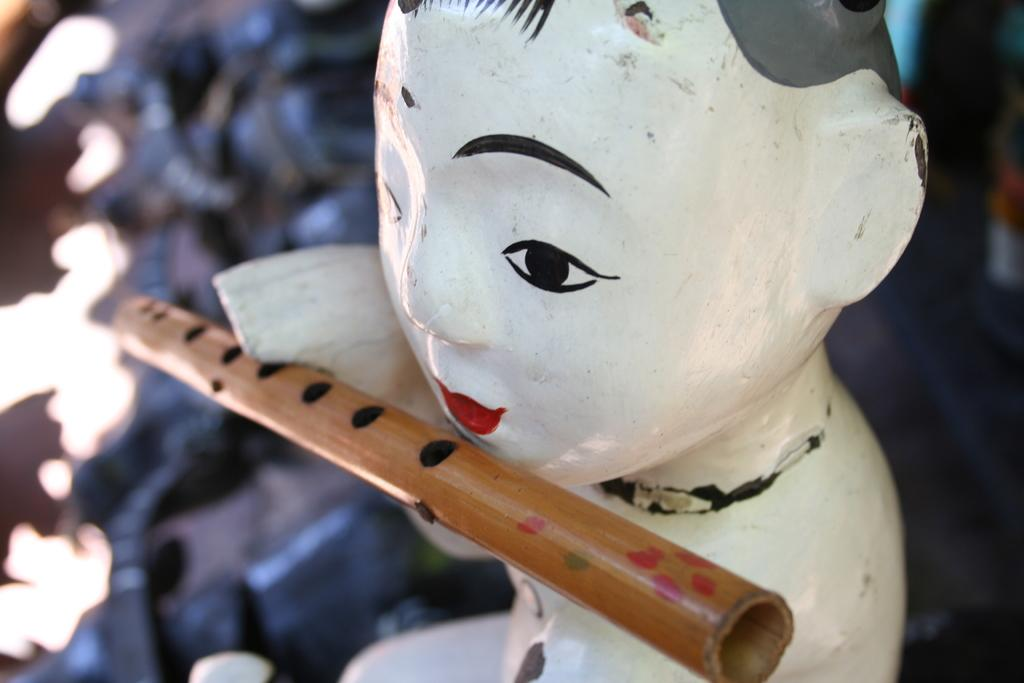What is the main subject of the image? There is a sculpture in the image. What is a notable feature of the sculpture? The sculpture has a wooden flute. Can you describe the background of the image? The background of the image is blurred. What type of apparatus is used to measure pollution in the image? There is no apparatus or mention of pollution in the image; it features a sculpture with a wooden flute and a blurred background. 